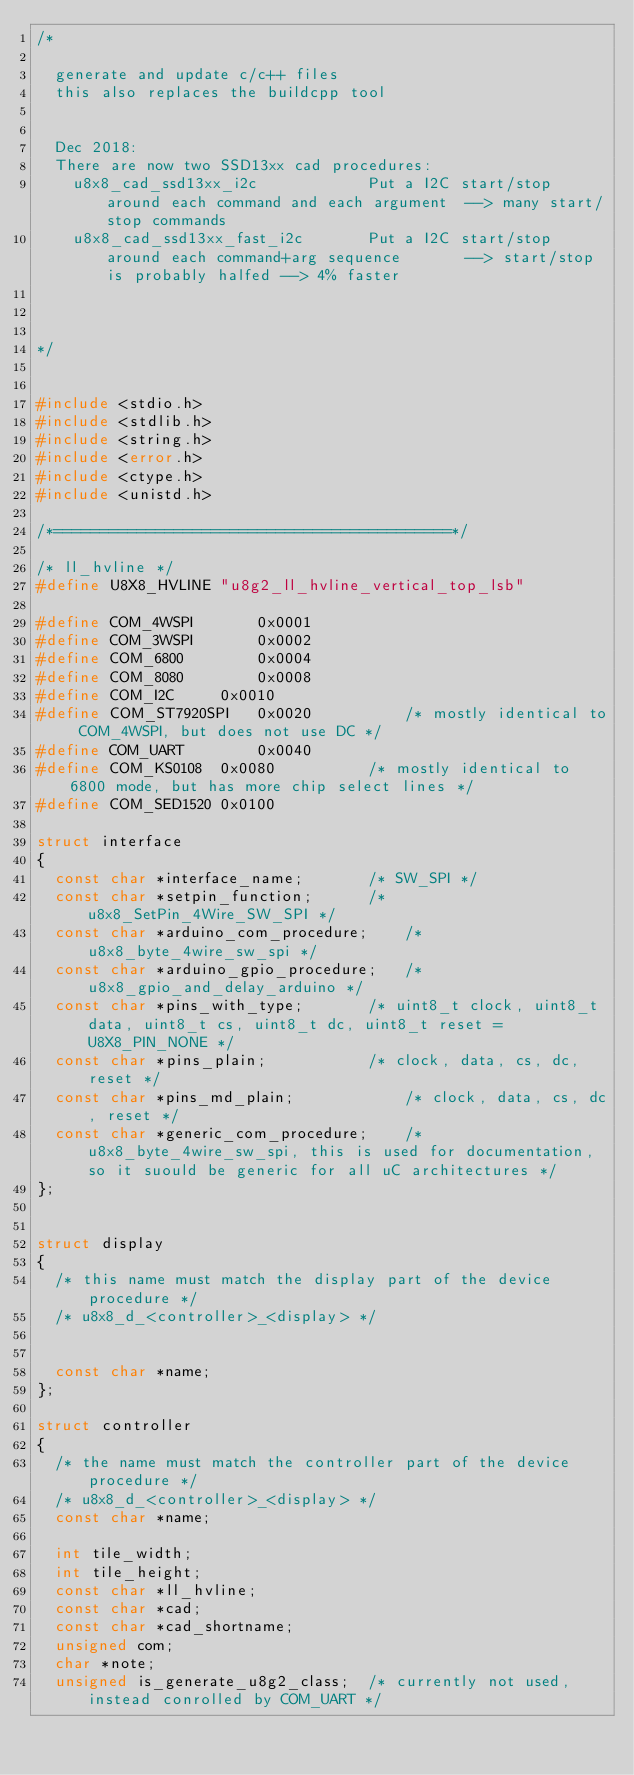Convert code to text. <code><loc_0><loc_0><loc_500><loc_500><_C_>/*

  generate and update c/c++ files
  this also replaces the buildcpp tool
  
  
  Dec 2018:
  There are now two SSD13xx cad procedures:
    u8x8_cad_ssd13xx_i2c			Put a I2C start/stop around each command and each argument	--> many start/stop commands
    u8x8_cad_ssd13xx_fast_i2c		Put a I2C start/stop around each command+arg sequence		--> start/stop is probably halfed --> 4% faster

  

*/


#include <stdio.h>
#include <stdlib.h>
#include <string.h>
#include <error.h>
#include <ctype.h>
#include <unistd.h>

/*===========================================*/

/* ll_hvline */
#define U8X8_HVLINE "u8g2_ll_hvline_vertical_top_lsb"

#define COM_4WSPI		0x0001
#define COM_3WSPI		0x0002
#define COM_6800		0x0004
#define COM_8080		0x0008
#define COM_I2C		0x0010
#define COM_ST7920SPI	0x0020			/* mostly identical to COM_4WSPI, but does not use DC */
#define COM_UART		0x0040
#define COM_KS0108	0x0080			/* mostly identical to 6800 mode, but has more chip select lines */
#define COM_SED1520	0x0100			

struct interface
{
  const char *interface_name;		/* SW_SPI */
  const char *setpin_function;		/* u8x8_SetPin_4Wire_SW_SPI */
  const char *arduino_com_procedure;	/* u8x8_byte_4wire_sw_spi */
  const char *arduino_gpio_procedure;	/* u8x8_gpio_and_delay_arduino */
  const char *pins_with_type;		/* uint8_t clock, uint8_t data, uint8_t cs, uint8_t dc, uint8_t reset = U8X8_PIN_NONE */
  const char *pins_plain;			/* clock, data, cs, dc, reset */
  const char *pins_md_plain;			/* clock, data, cs, dc, reset */
  const char *generic_com_procedure;	/* u8x8_byte_4wire_sw_spi, this is used for documentation, so it suould be generic for all uC architectures */
};


struct display
{
  /* this name must match the display part of the device procedure */
  /* u8x8_d_<controller>_<display> */
  

  const char *name;	
};

struct controller
{
  /* the name must match the controller part of the device procedure */
  /* u8x8_d_<controller>_<display> */
  const char *name;
  
  int tile_width;
  int tile_height;
  const char *ll_hvline;
  const char *cad;
  const char *cad_shortname;
  unsigned com;
  char *note;
  unsigned is_generate_u8g2_class;	/* currently not used, instead conrolled by COM_UART */</code> 